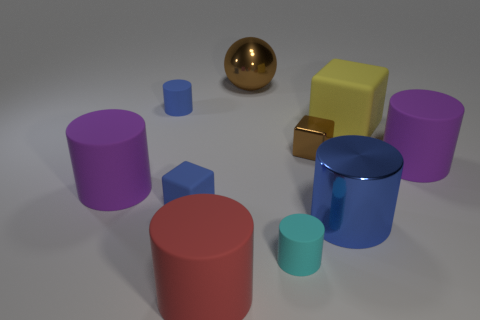Do the tiny shiny cube and the sphere have the same color?
Provide a succinct answer. Yes. Are there any purple things left of the large metal thing in front of the purple rubber thing on the right side of the small brown block?
Offer a very short reply. Yes. There is a large blue object that is the same shape as the large red rubber object; what material is it?
Provide a succinct answer. Metal. Is the big sphere made of the same material as the big blue object that is in front of the yellow matte object?
Ensure brevity in your answer.  Yes. The purple thing on the left side of the blue object behind the small brown metal block is what shape?
Your response must be concise. Cylinder. What number of big objects are cyan objects or purple matte objects?
Ensure brevity in your answer.  2. What number of red objects are the same shape as the small brown object?
Keep it short and to the point. 0. There is a large red matte object; is it the same shape as the big shiny thing behind the blue matte block?
Keep it short and to the point. No. What number of big red rubber objects are right of the cyan cylinder?
Make the answer very short. 0. Are there any shiny balls that have the same size as the yellow object?
Make the answer very short. Yes. 